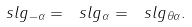<formula> <loc_0><loc_0><loc_500><loc_500>\ s l g _ { - \alpha } = \ s l g _ { \alpha } = \ s l g _ { \theta \alpha } .</formula> 